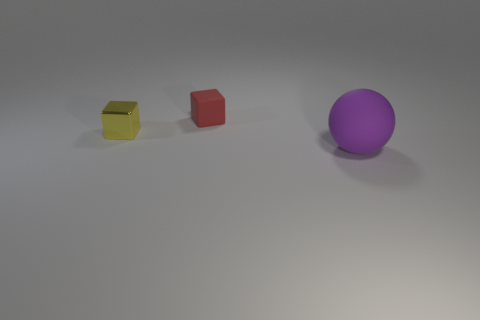Subtract all red blocks. How many blocks are left? 1 Subtract all cubes. How many objects are left? 1 Add 2 small yellow balls. How many objects exist? 5 Subtract 1 cubes. How many cubes are left? 1 Add 1 yellow shiny cubes. How many yellow shiny cubes are left? 2 Add 1 large yellow objects. How many large yellow objects exist? 1 Subtract 0 yellow cylinders. How many objects are left? 3 Subtract all gray blocks. Subtract all green spheres. How many blocks are left? 2 Subtract all brown cubes. How many cyan balls are left? 0 Subtract all big gray matte objects. Subtract all tiny yellow objects. How many objects are left? 2 